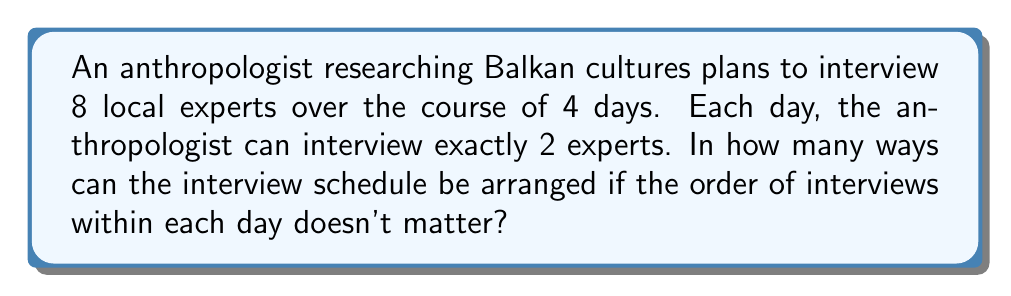Provide a solution to this math problem. Let's approach this step-by-step:

1) First, we need to choose which 2 experts will be interviewed on day 1. This is a combination problem, as the order within the day doesn't matter. We can select 2 experts from 8 in $\binom{8}{2}$ ways.

2) After day 1, we have 6 experts left. We need to choose 2 for day 2. This can be done in $\binom{6}{2}$ ways.

3) For day 3, we have 4 experts left, so we can choose 2 in $\binom{4}{2}$ ways.

4) For the last day, we have no choice as we must interview the remaining 2 experts. This can be done in $\binom{2}{2} = 1$ way.

5) By the multiplication principle, the total number of ways to arrange the schedule is:

   $$\binom{8}{2} \cdot \binom{6}{2} \cdot \binom{4}{2} \cdot \binom{2}{2}$$

6) Let's calculate each combination:

   $\binom{8}{2} = \frac{8!}{2!(8-2)!} = \frac{8 \cdot 7}{2 \cdot 1} = 28$

   $\binom{6}{2} = \frac{6!}{2!(6-2)!} = \frac{6 \cdot 5}{2 \cdot 1} = 15$

   $\binom{4}{2} = \frac{4!}{2!(4-2)!} = \frac{4 \cdot 3}{2 \cdot 1} = 6$

   $\binom{2}{2} = \frac{2!}{2!(2-2)!} = 1$

7) Multiplying these together:

   $28 \cdot 15 \cdot 6 \cdot 1 = 2,520$

Therefore, there are 2,520 possible ways to arrange the interview schedule.
Answer: 2,520 